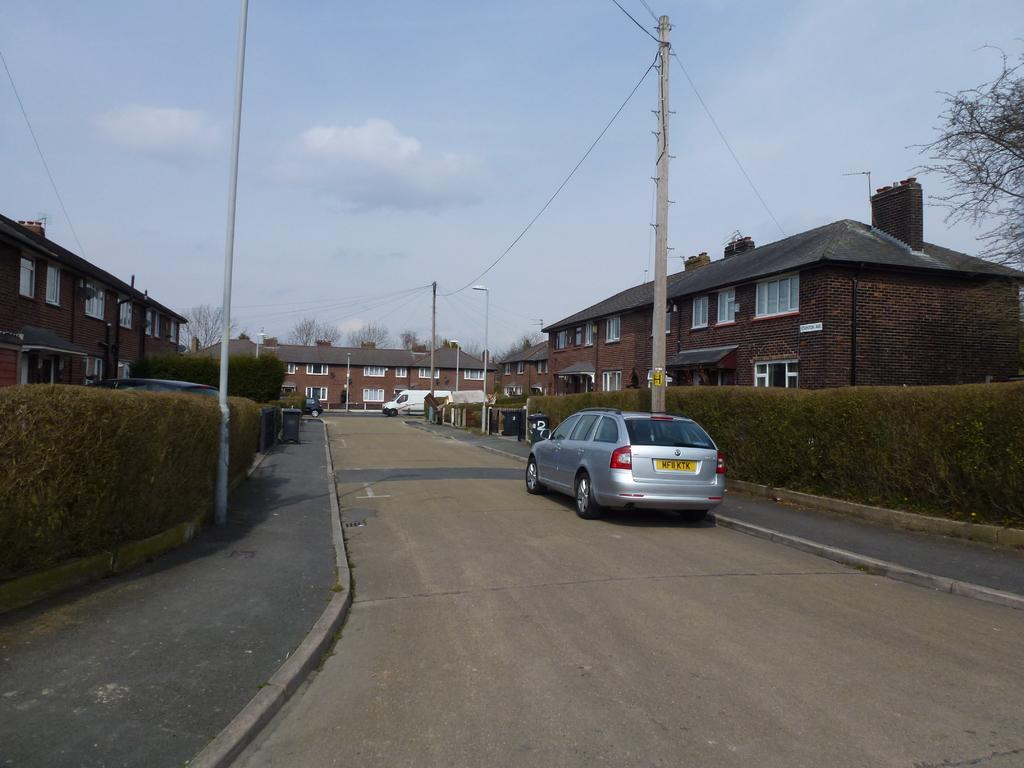What type of structures can be seen in the image? There are buildings in the image. What other natural elements are present in the image? There are trees in the image. What mode of transportation can be seen on the road in the image? There are cars on the road in the image. What type of vertical structures are present in the image? There are poles in the image. Can you describe the pole that has a light attached to it? There is a pole light in the image. How would you describe the sky in the image? The sky is blue and cloudy in the image. Where is the father sitting in the image? There is no father present in the image. Can you see a boat in the image? There is no boat present in the image. 